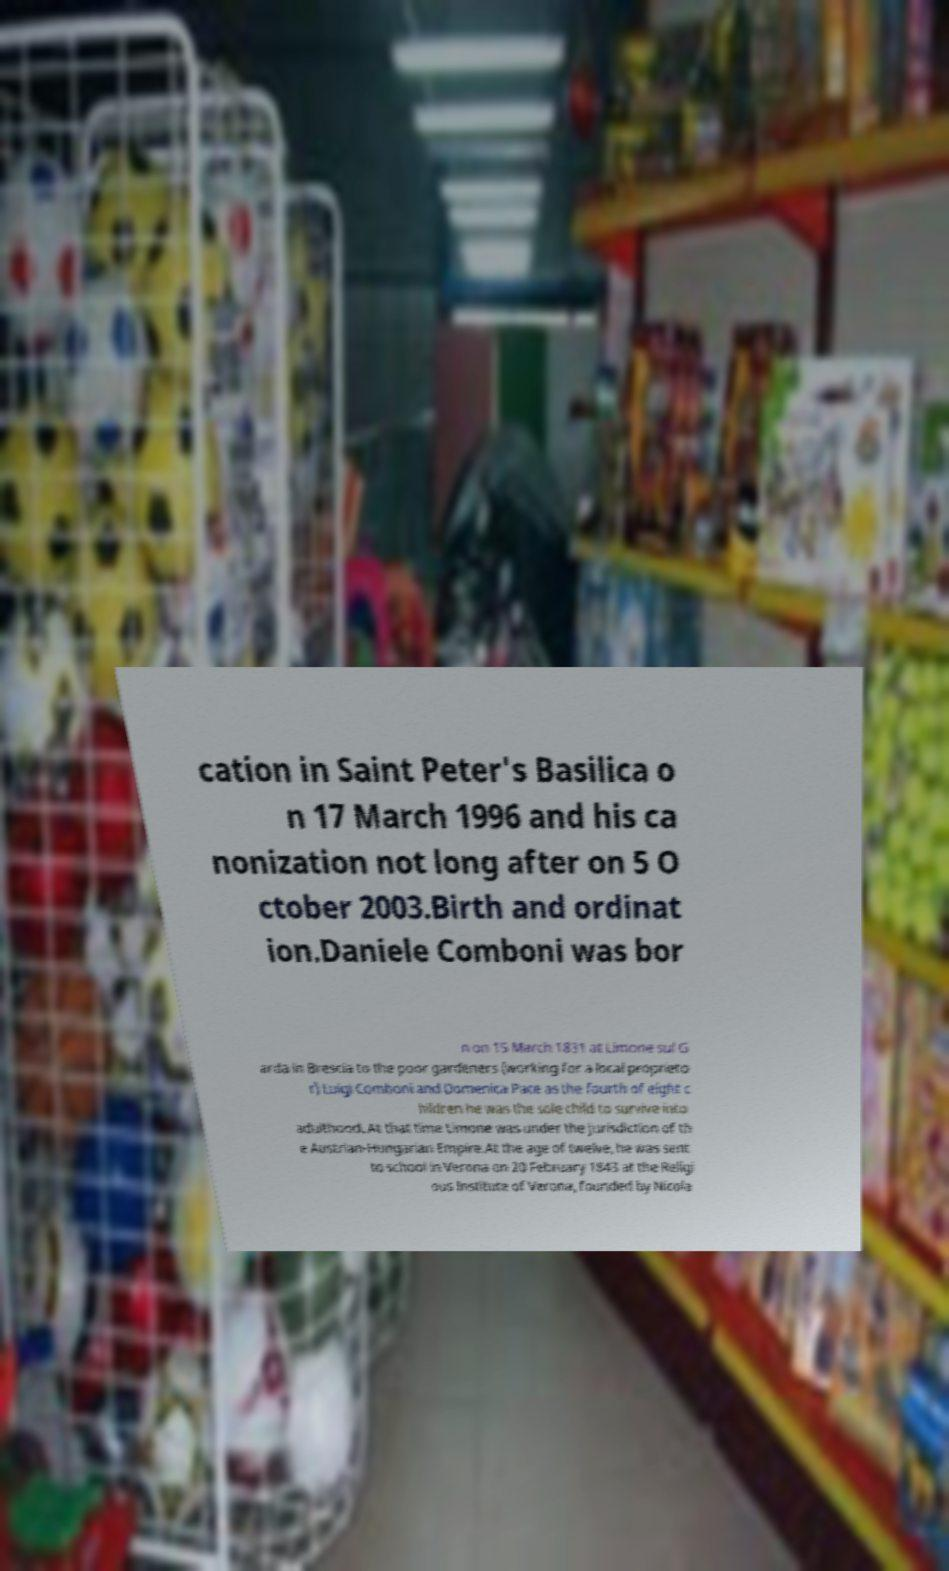There's text embedded in this image that I need extracted. Can you transcribe it verbatim? cation in Saint Peter's Basilica o n 17 March 1996 and his ca nonization not long after on 5 O ctober 2003.Birth and ordinat ion.Daniele Comboni was bor n on 15 March 1831 at Limone sul G arda in Brescia to the poor gardeners (working for a local proprieto r) Luigi Comboni and Domenica Pace as the fourth of eight c hildren he was the sole child to survive into adulthood. At that time Limone was under the jurisdiction of th e Austrian-Hungarian Empire.At the age of twelve, he was sent to school in Verona on 20 February 1843 at the Religi ous Institute of Verona, founded by Nicola 